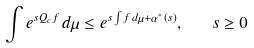<formula> <loc_0><loc_0><loc_500><loc_500>\int e ^ { s Q _ { c } f } \, d \mu \leq e ^ { s \int f \, d \mu + \alpha ^ { * } ( s ) } , \quad s \geq 0</formula> 